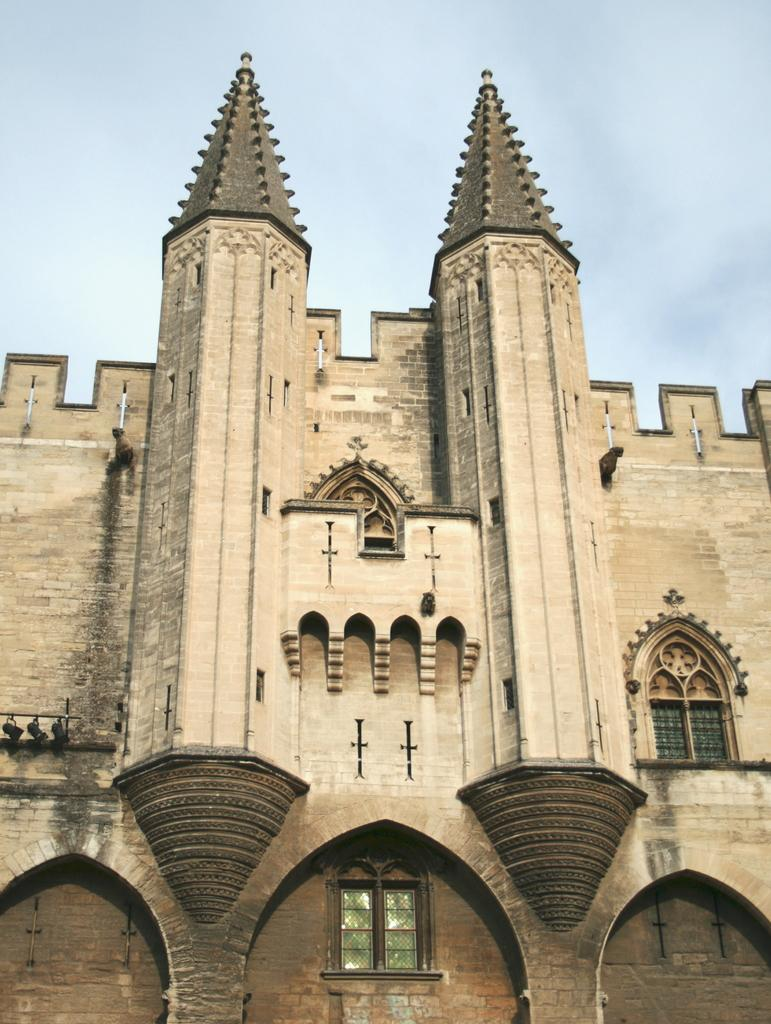What type of building is in the picture? There is a church in the picture. Where is the window located in the picture? The window is at the bottom of the picture. What can be seen at the top of the picture? The sky is visible at the top of the picture. What is the condition of the sky in the picture? Clouds are present in the sky. What type of pump can be seen near the church in the image? There is no pump present in the image; it features a church and a window at the bottom, with clouds in the sky. 